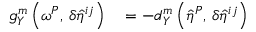Convert formula to latex. <formula><loc_0><loc_0><loc_500><loc_500>\begin{array} { r l } { g _ { Y } ^ { m } \left ( { \omega ^ { P } } , \, { \delta \hat { \eta } ^ { i j } } \right ) } & = - d _ { Y } ^ { m } \left ( { \hat { \eta } ^ { P } } , \, { \delta \hat { \eta } ^ { i j } } \right ) } \end{array}</formula> 